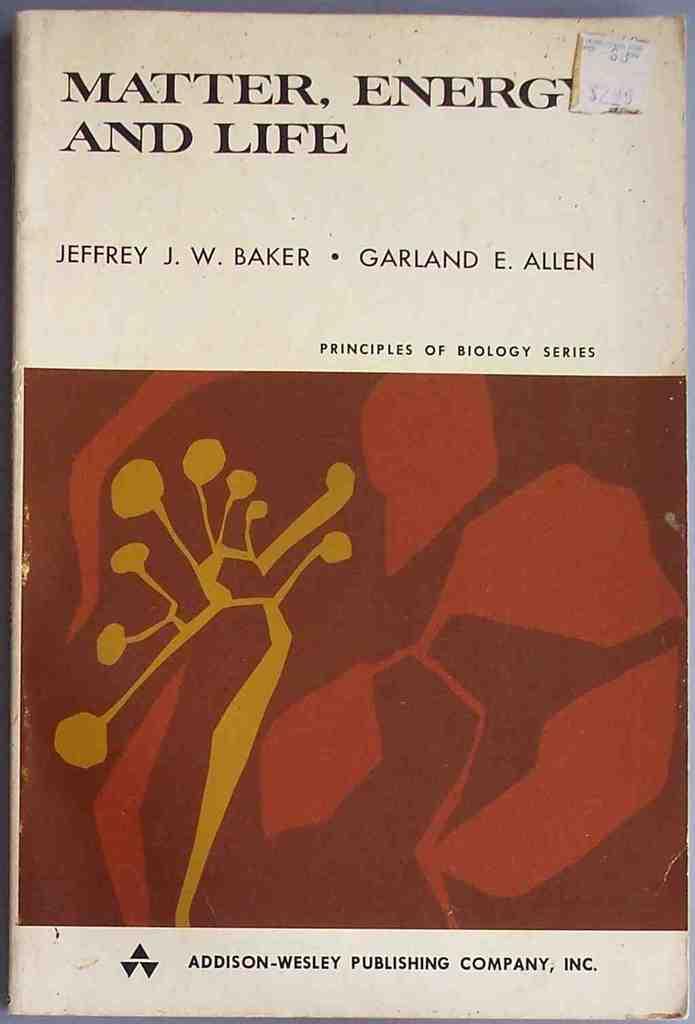What is the title of this book?
Keep it short and to the point. Matter, energy and life. Who published this book?
Your response must be concise. Addison-wesley. 